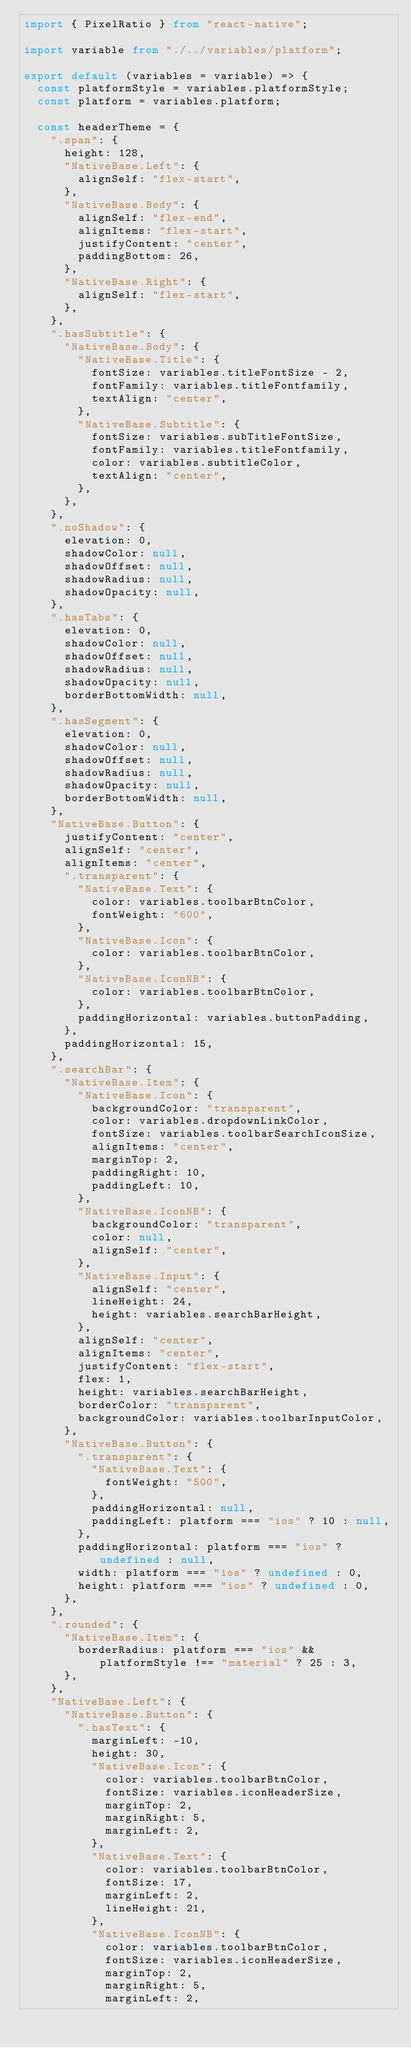<code> <loc_0><loc_0><loc_500><loc_500><_TypeScript_>import { PixelRatio } from "react-native";

import variable from "./../variables/platform";

export default (variables = variable) => {
	const platformStyle = variables.platformStyle;
	const platform = variables.platform;

	const headerTheme = {
		".span": {
			height: 128,
			"NativeBase.Left": {
				alignSelf: "flex-start",
			},
			"NativeBase.Body": {
				alignSelf: "flex-end",
				alignItems: "flex-start",
				justifyContent: "center",
				paddingBottom: 26,
			},
			"NativeBase.Right": {
				alignSelf: "flex-start",
			},
		},
		".hasSubtitle": {
			"NativeBase.Body": {
				"NativeBase.Title": {
					fontSize: variables.titleFontSize - 2,
					fontFamily: variables.titleFontfamily,
					textAlign: "center",
				},
				"NativeBase.Subtitle": {
					fontSize: variables.subTitleFontSize,
					fontFamily: variables.titleFontfamily,
					color: variables.subtitleColor,
					textAlign: "center",
				},
			},
		},
		".noShadow": {
			elevation: 0,
			shadowColor: null,
			shadowOffset: null,
			shadowRadius: null,
			shadowOpacity: null,
		},
		".hasTabs": {
			elevation: 0,
			shadowColor: null,
			shadowOffset: null,
			shadowRadius: null,
			shadowOpacity: null,
			borderBottomWidth: null,
		},
		".hasSegment": {
			elevation: 0,
			shadowColor: null,
			shadowOffset: null,
			shadowRadius: null,
			shadowOpacity: null,
			borderBottomWidth: null,
		},
		"NativeBase.Button": {
			justifyContent: "center",
			alignSelf: "center",
			alignItems: "center",
			".transparent": {
				"NativeBase.Text": {
					color: variables.toolbarBtnColor,
					fontWeight: "600",
				},
				"NativeBase.Icon": {
					color: variables.toolbarBtnColor,
				},
				"NativeBase.IconNB": {
					color: variables.toolbarBtnColor,
				},
				paddingHorizontal: variables.buttonPadding,
			},
			paddingHorizontal: 15,
		},
		".searchBar": {
			"NativeBase.Item": {
				"NativeBase.Icon": {
					backgroundColor: "transparent",
					color: variables.dropdownLinkColor,
					fontSize: variables.toolbarSearchIconSize,
					alignItems: "center",
					marginTop: 2,
					paddingRight: 10,
					paddingLeft: 10,
				},
				"NativeBase.IconNB": {
					backgroundColor: "transparent",
					color: null,
					alignSelf: "center",
				},
				"NativeBase.Input": {
					alignSelf: "center",
					lineHeight: 24,
					height: variables.searchBarHeight,
				},
				alignSelf: "center",
				alignItems: "center",
				justifyContent: "flex-start",
				flex: 1,
				height: variables.searchBarHeight,
				borderColor: "transparent",
				backgroundColor: variables.toolbarInputColor,
			},
			"NativeBase.Button": {
				".transparent": {
					"NativeBase.Text": {
						fontWeight: "500",
					},
					paddingHorizontal: null,
					paddingLeft: platform === "ios" ? 10 : null,
				},
				paddingHorizontal: platform === "ios" ? undefined : null,
				width: platform === "ios" ? undefined : 0,
				height: platform === "ios" ? undefined : 0,
			},
		},
		".rounded": {
			"NativeBase.Item": {
				borderRadius: platform === "ios" && platformStyle !== "material" ? 25 : 3,
			},
		},
		"NativeBase.Left": {
			"NativeBase.Button": {
				".hasText": {
					marginLeft: -10,
					height: 30,
					"NativeBase.Icon": {
						color: variables.toolbarBtnColor,
						fontSize: variables.iconHeaderSize,
						marginTop: 2,
						marginRight: 5,
						marginLeft: 2,
					},
					"NativeBase.Text": {
						color: variables.toolbarBtnColor,
						fontSize: 17,
						marginLeft: 2,
						lineHeight: 21,
					},
					"NativeBase.IconNB": {
						color: variables.toolbarBtnColor,
						fontSize: variables.iconHeaderSize,
						marginTop: 2,
						marginRight: 5,
						marginLeft: 2,</code> 